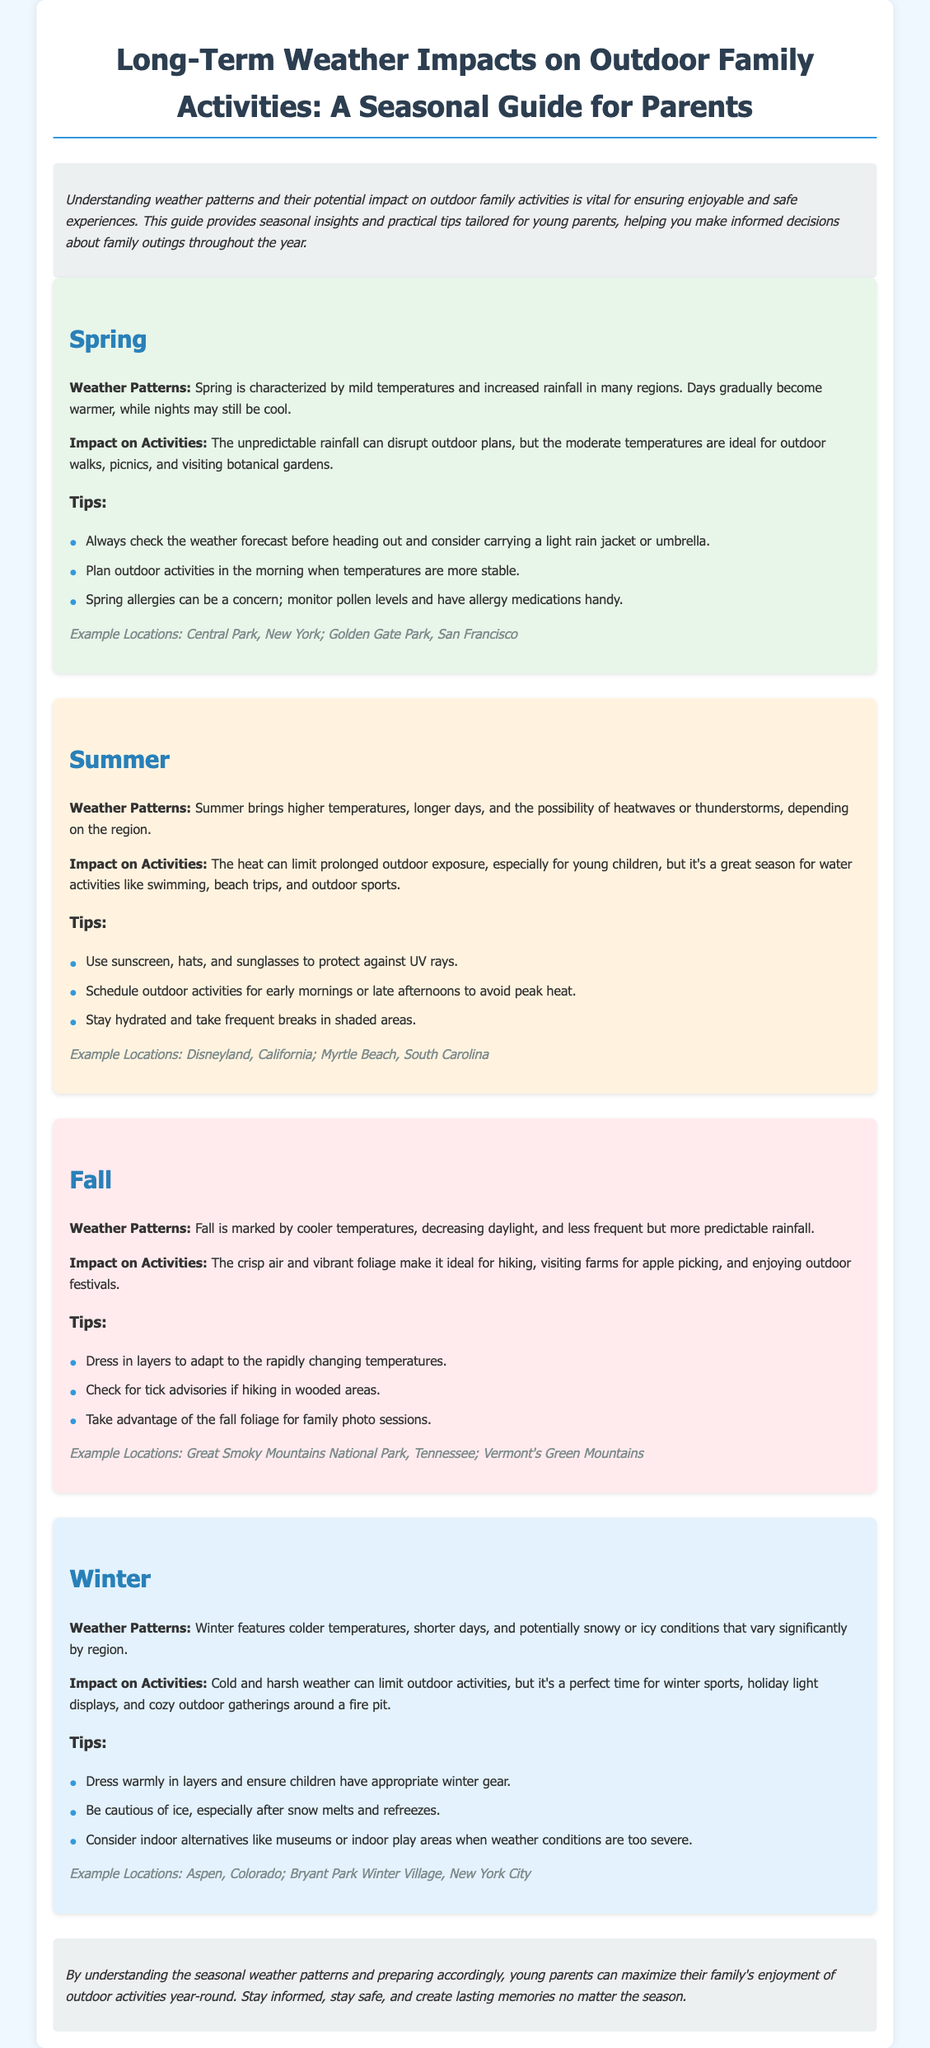What is a characteristic of spring weather? Spring is characterized by mild temperatures and increased rainfall in many regions.
Answer: Mild temperatures and increased rainfall What activities are suitable for summer? The heat can limit prolonged outdoor exposure, but it's a great season for water activities like swimming, beach trips, and outdoor sports.
Answer: Swimming, beach trips, outdoor sports What should you monitor during spring? Spring allergies can be a concern; monitor pollen levels and have allergy medications handy.
Answer: Pollen levels Which season is ideal for hiking? The crisp air and vibrant foliage make it ideal for hiking, visiting farms for apple picking, and enjoying outdoor festivals.
Answer: Fall What is a recommendation for winter activities? Dress warmly in layers and ensure children have appropriate winter gear.
Answer: Dress warmly in layers What type of policies does this document support? Understanding weather patterns and their potential impact on outdoor family activities is vital for ensuring enjoyable and safe experiences.
Answer: Family-friendly policies How should parents prepare for outdoor activities in summer? Schedule outdoor activities for early mornings or late afternoons to avoid peak heat.
Answer: Early mornings or late afternoons What notable feature affects fall weather? Fall is marked by cooler temperatures, decreasing daylight, and less frequent but more predictable rainfall.
Answer: Cooler temperatures and decreasing daylight 